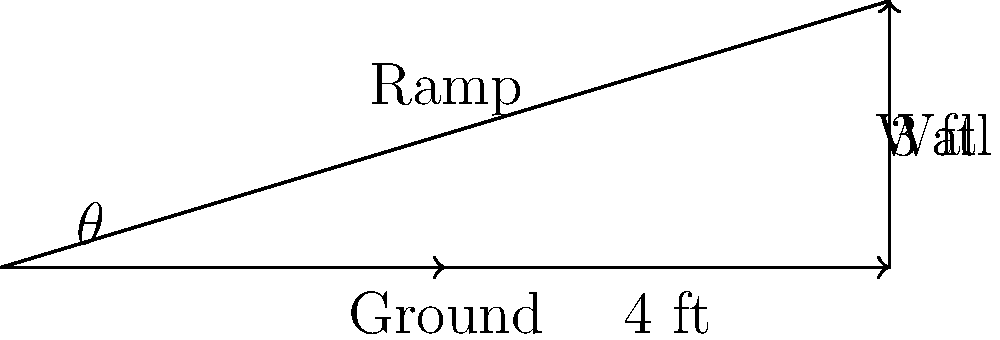You're designing a stylish pink ramp for your Chihuahua to easily access her favorite cushion on the sofa. The ramp needs to extend 4 feet from the sofa and reach a height of 3 feet. What is the optimal angle $\theta$ (in degrees) for the ramp to ensure your petite pooch can comfortably climb it? To find the optimal angle $\theta$ for the dog ramp, we can use the trigonometric function tangent (tan). Here's how we solve it step-by-step:

1) In a right triangle, tan $\theta$ is the ratio of the opposite side to the adjacent side.

2) In this case:
   - The opposite side (height) is 3 feet
   - The adjacent side (ground length) is 4 feet

3) We can set up the equation:
   $\tan \theta = \frac{\text{opposite}}{\text{adjacent}} = \frac{3}{4}$

4) To find $\theta$, we need to use the inverse tangent function (arctan or $\tan^{-1}$):
   $\theta = \tan^{-1}(\frac{3}{4})$

5) Using a calculator or computer:
   $\theta \approx 36.87°$

6) Rounding to the nearest degree:
   $\theta \approx 37°$

This angle should provide a comfortable slope for your Chihuahua to climb while maintaining stability and safety.
Answer: $37°$ 